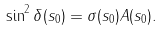<formula> <loc_0><loc_0><loc_500><loc_500>\sin ^ { 2 } \delta ( s _ { 0 } ) = \sigma ( s _ { 0 } ) A ( s _ { 0 } ) .</formula> 